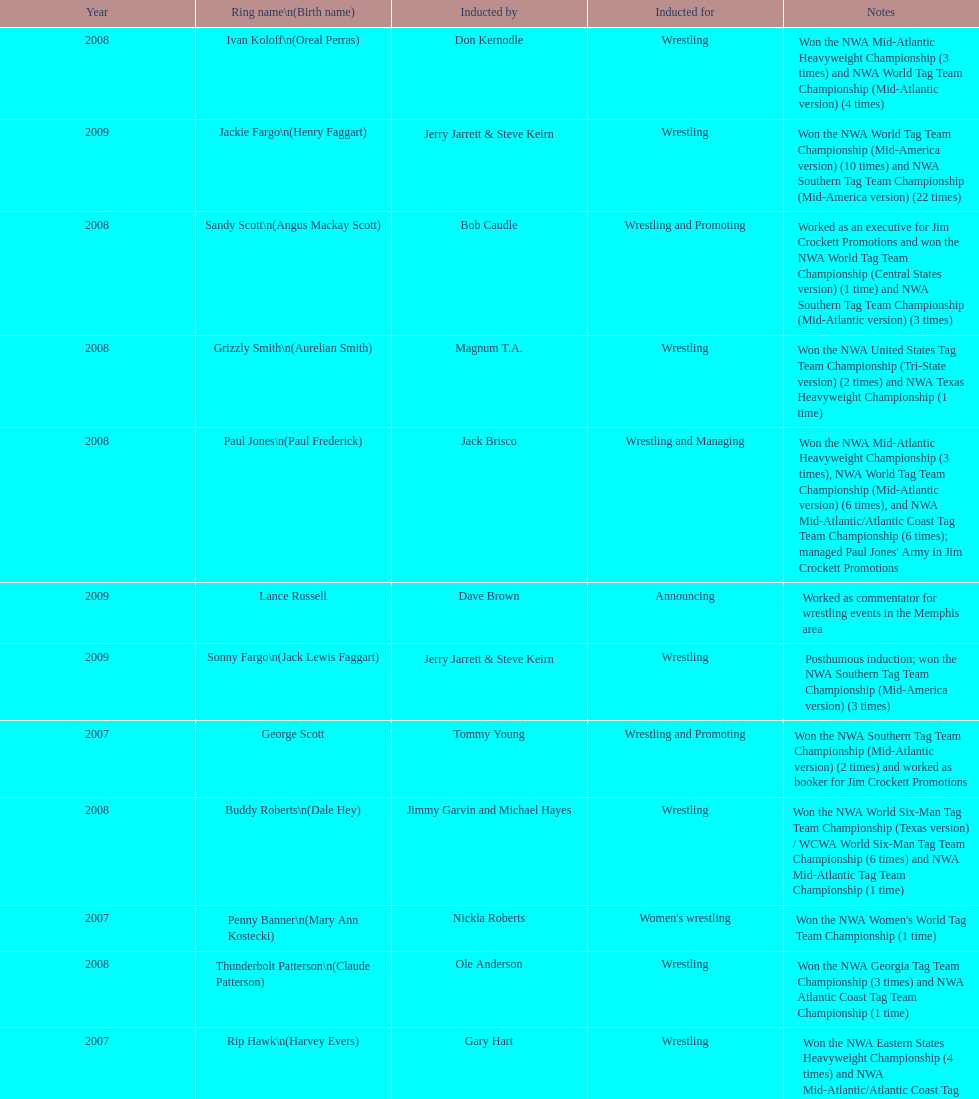Who was the only person to be inducted for wrestling and managing? Paul Jones. 